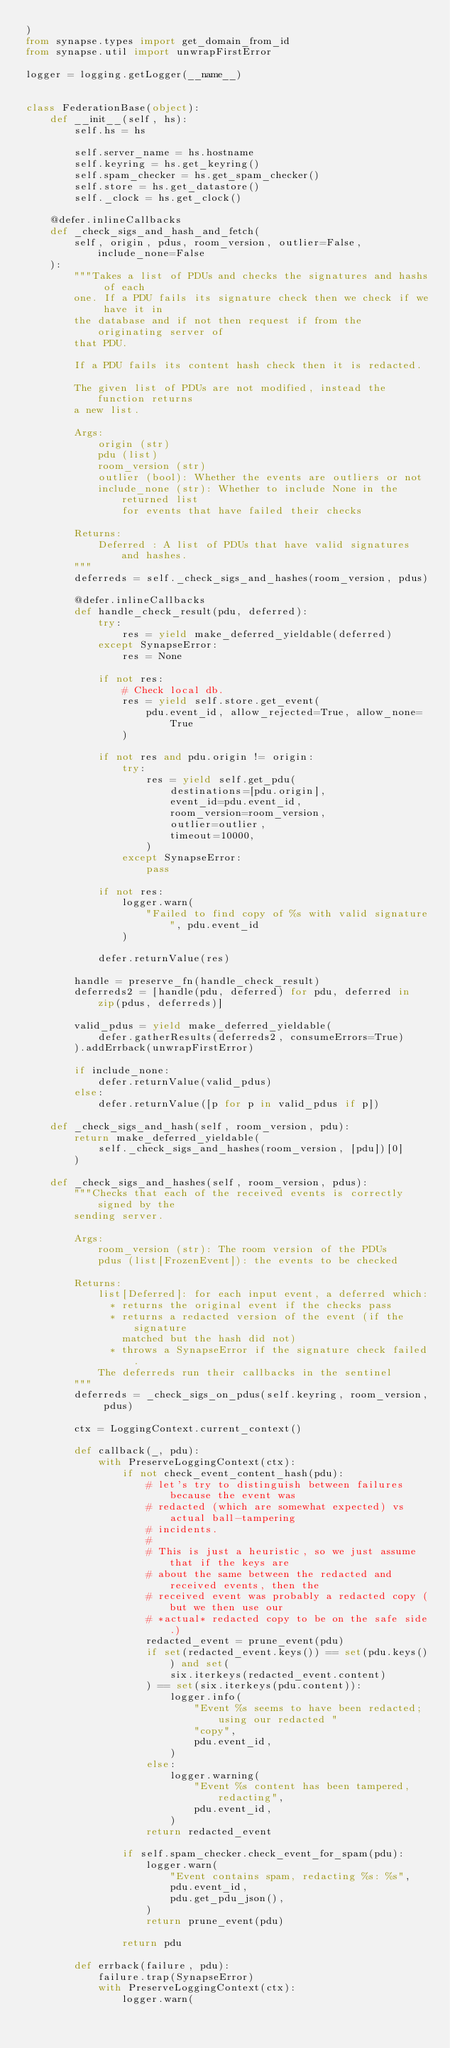Convert code to text. <code><loc_0><loc_0><loc_500><loc_500><_Python_>)
from synapse.types import get_domain_from_id
from synapse.util import unwrapFirstError

logger = logging.getLogger(__name__)


class FederationBase(object):
    def __init__(self, hs):
        self.hs = hs

        self.server_name = hs.hostname
        self.keyring = hs.get_keyring()
        self.spam_checker = hs.get_spam_checker()
        self.store = hs.get_datastore()
        self._clock = hs.get_clock()

    @defer.inlineCallbacks
    def _check_sigs_and_hash_and_fetch(
        self, origin, pdus, room_version, outlier=False, include_none=False
    ):
        """Takes a list of PDUs and checks the signatures and hashs of each
        one. If a PDU fails its signature check then we check if we have it in
        the database and if not then request if from the originating server of
        that PDU.

        If a PDU fails its content hash check then it is redacted.

        The given list of PDUs are not modified, instead the function returns
        a new list.

        Args:
            origin (str)
            pdu (list)
            room_version (str)
            outlier (bool): Whether the events are outliers or not
            include_none (str): Whether to include None in the returned list
                for events that have failed their checks

        Returns:
            Deferred : A list of PDUs that have valid signatures and hashes.
        """
        deferreds = self._check_sigs_and_hashes(room_version, pdus)

        @defer.inlineCallbacks
        def handle_check_result(pdu, deferred):
            try:
                res = yield make_deferred_yieldable(deferred)
            except SynapseError:
                res = None

            if not res:
                # Check local db.
                res = yield self.store.get_event(
                    pdu.event_id, allow_rejected=True, allow_none=True
                )

            if not res and pdu.origin != origin:
                try:
                    res = yield self.get_pdu(
                        destinations=[pdu.origin],
                        event_id=pdu.event_id,
                        room_version=room_version,
                        outlier=outlier,
                        timeout=10000,
                    )
                except SynapseError:
                    pass

            if not res:
                logger.warn(
                    "Failed to find copy of %s with valid signature", pdu.event_id
                )

            defer.returnValue(res)

        handle = preserve_fn(handle_check_result)
        deferreds2 = [handle(pdu, deferred) for pdu, deferred in zip(pdus, deferreds)]

        valid_pdus = yield make_deferred_yieldable(
            defer.gatherResults(deferreds2, consumeErrors=True)
        ).addErrback(unwrapFirstError)

        if include_none:
            defer.returnValue(valid_pdus)
        else:
            defer.returnValue([p for p in valid_pdus if p])

    def _check_sigs_and_hash(self, room_version, pdu):
        return make_deferred_yieldable(
            self._check_sigs_and_hashes(room_version, [pdu])[0]
        )

    def _check_sigs_and_hashes(self, room_version, pdus):
        """Checks that each of the received events is correctly signed by the
        sending server.

        Args:
            room_version (str): The room version of the PDUs
            pdus (list[FrozenEvent]): the events to be checked

        Returns:
            list[Deferred]: for each input event, a deferred which:
              * returns the original event if the checks pass
              * returns a redacted version of the event (if the signature
                matched but the hash did not)
              * throws a SynapseError if the signature check failed.
            The deferreds run their callbacks in the sentinel
        """
        deferreds = _check_sigs_on_pdus(self.keyring, room_version, pdus)

        ctx = LoggingContext.current_context()

        def callback(_, pdu):
            with PreserveLoggingContext(ctx):
                if not check_event_content_hash(pdu):
                    # let's try to distinguish between failures because the event was
                    # redacted (which are somewhat expected) vs actual ball-tampering
                    # incidents.
                    #
                    # This is just a heuristic, so we just assume that if the keys are
                    # about the same between the redacted and received events, then the
                    # received event was probably a redacted copy (but we then use our
                    # *actual* redacted copy to be on the safe side.)
                    redacted_event = prune_event(pdu)
                    if set(redacted_event.keys()) == set(pdu.keys()) and set(
                        six.iterkeys(redacted_event.content)
                    ) == set(six.iterkeys(pdu.content)):
                        logger.info(
                            "Event %s seems to have been redacted; using our redacted "
                            "copy",
                            pdu.event_id,
                        )
                    else:
                        logger.warning(
                            "Event %s content has been tampered, redacting",
                            pdu.event_id,
                        )
                    return redacted_event

                if self.spam_checker.check_event_for_spam(pdu):
                    logger.warn(
                        "Event contains spam, redacting %s: %s",
                        pdu.event_id,
                        pdu.get_pdu_json(),
                    )
                    return prune_event(pdu)

                return pdu

        def errback(failure, pdu):
            failure.trap(SynapseError)
            with PreserveLoggingContext(ctx):
                logger.warn(</code> 